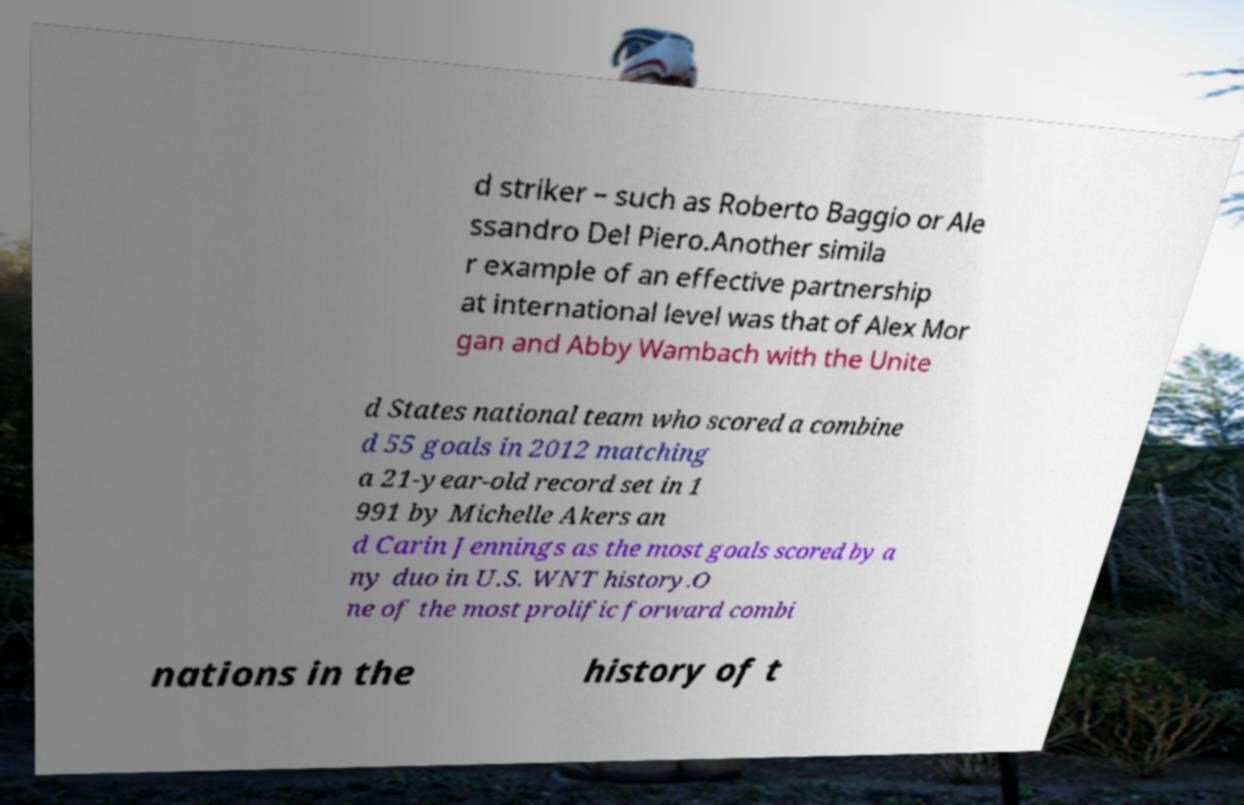Could you extract and type out the text from this image? d striker – such as Roberto Baggio or Ale ssandro Del Piero.Another simila r example of an effective partnership at international level was that of Alex Mor gan and Abby Wambach with the Unite d States national team who scored a combine d 55 goals in 2012 matching a 21-year-old record set in 1 991 by Michelle Akers an d Carin Jennings as the most goals scored by a ny duo in U.S. WNT history.O ne of the most prolific forward combi nations in the history of t 